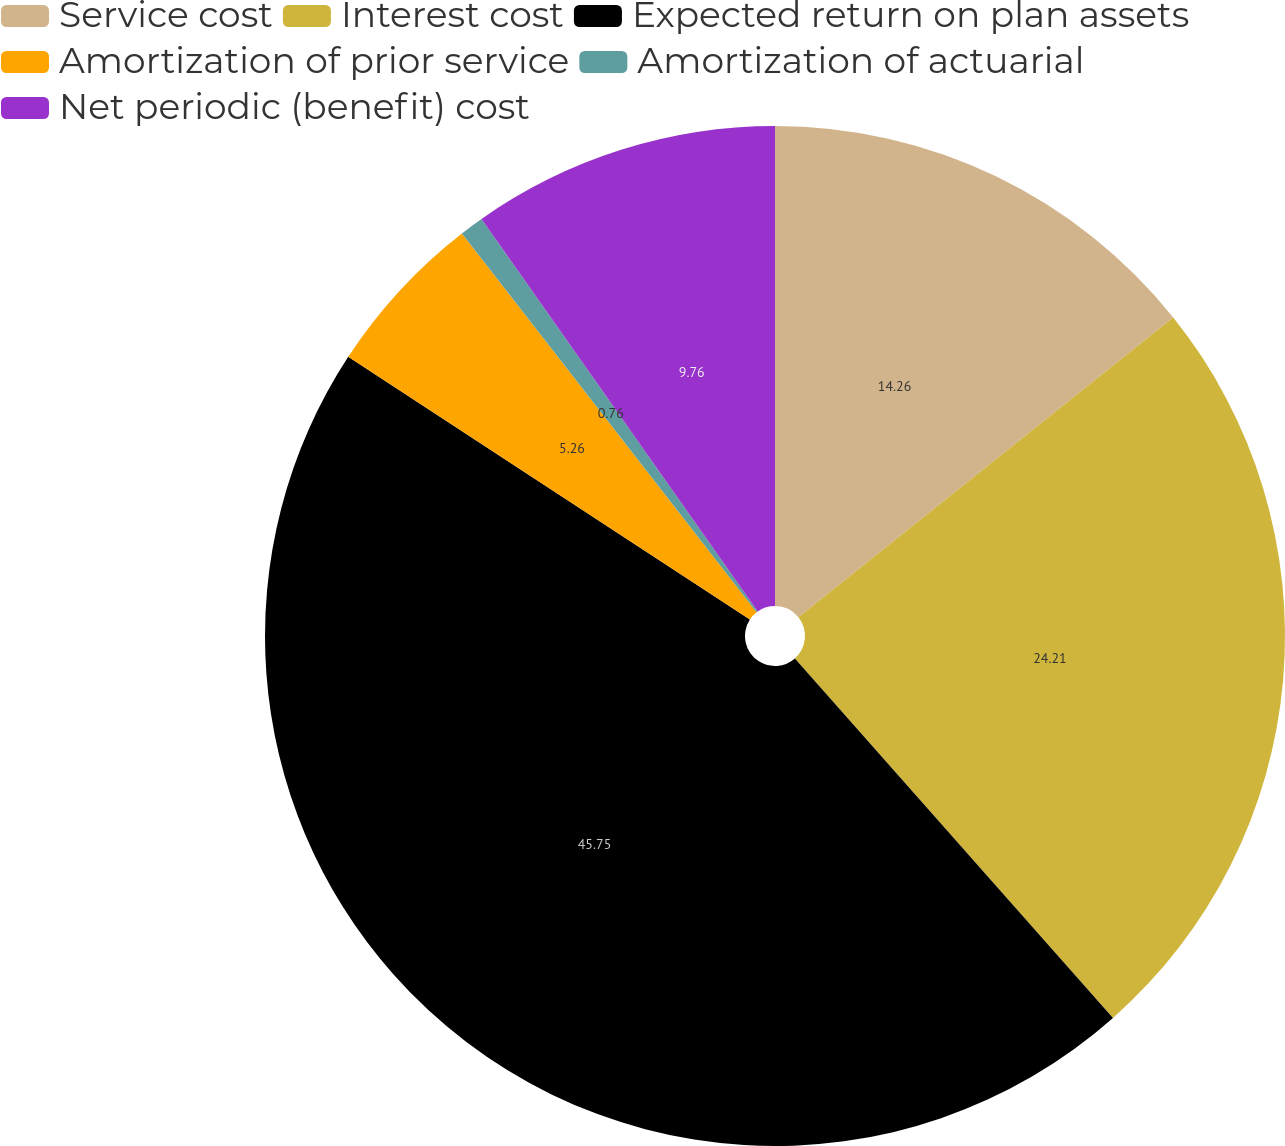Convert chart to OTSL. <chart><loc_0><loc_0><loc_500><loc_500><pie_chart><fcel>Service cost<fcel>Interest cost<fcel>Expected return on plan assets<fcel>Amortization of prior service<fcel>Amortization of actuarial<fcel>Net periodic (benefit) cost<nl><fcel>14.26%<fcel>24.21%<fcel>45.75%<fcel>5.26%<fcel>0.76%<fcel>9.76%<nl></chart> 